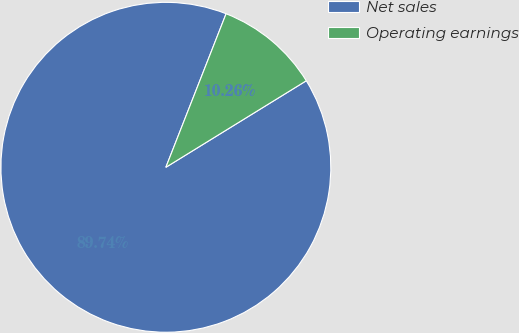<chart> <loc_0><loc_0><loc_500><loc_500><pie_chart><fcel>Net sales<fcel>Operating earnings<nl><fcel>89.74%<fcel>10.26%<nl></chart> 